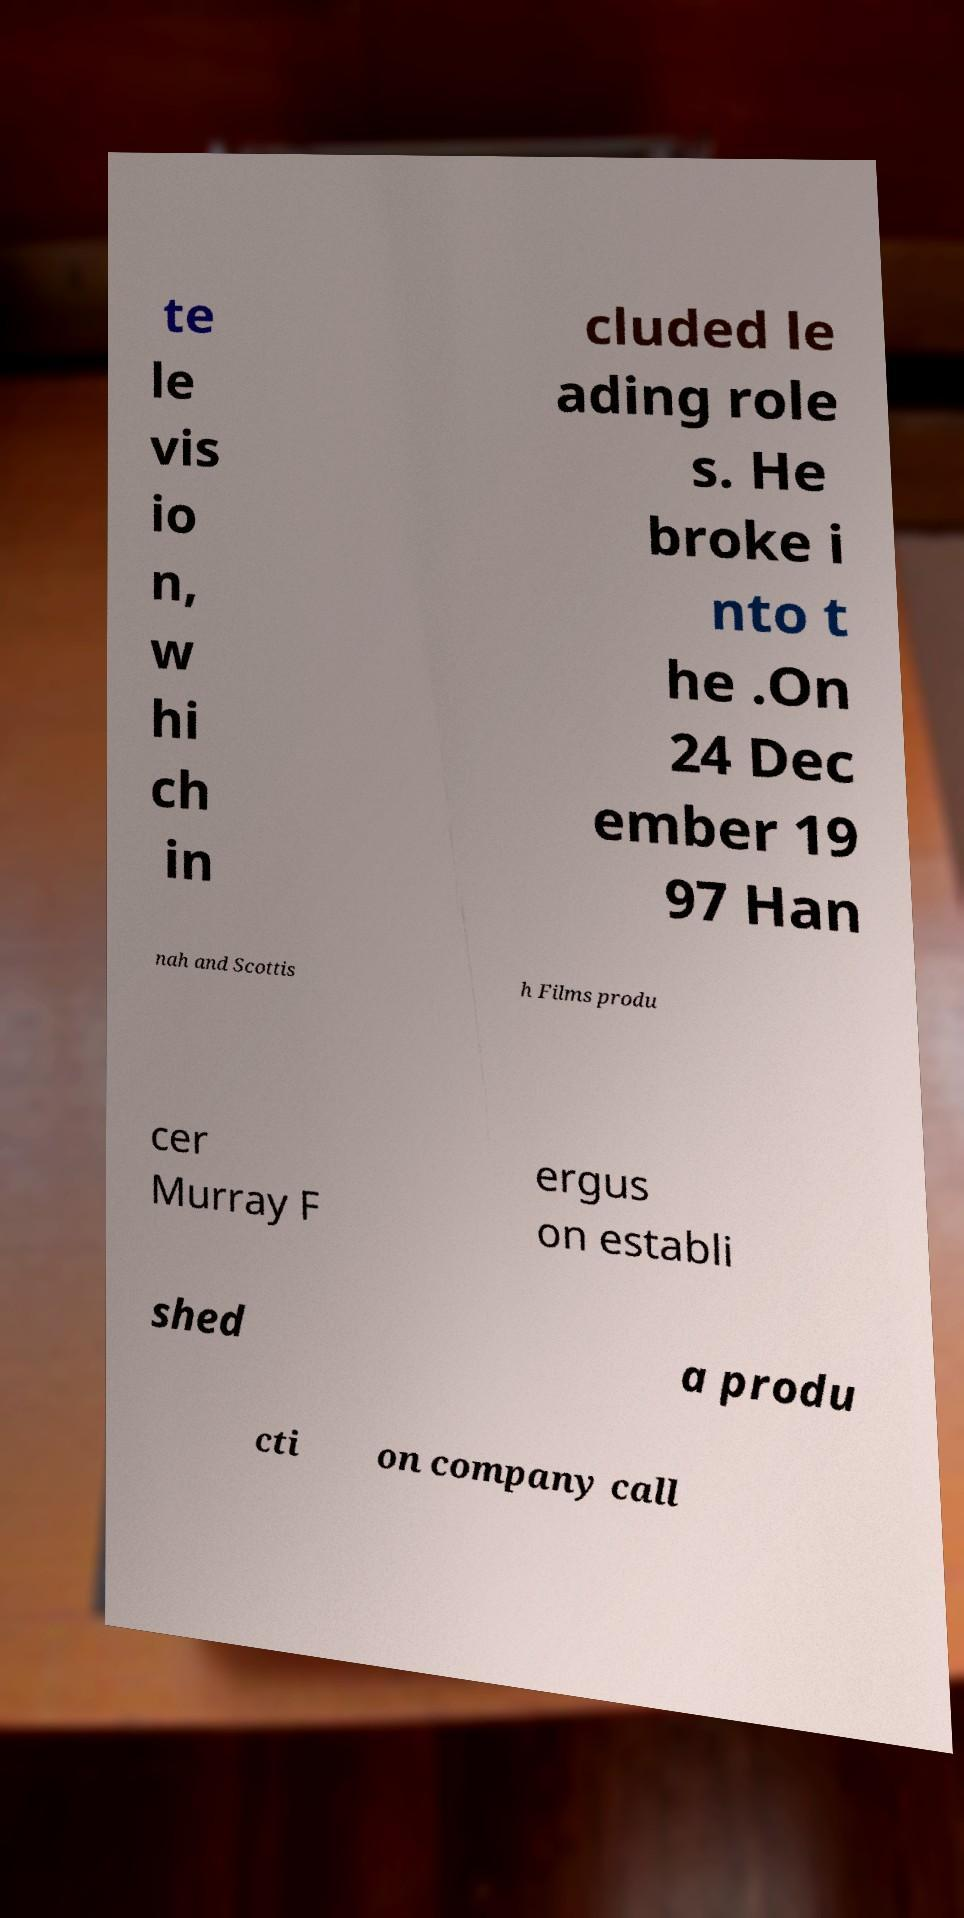Please read and relay the text visible in this image. What does it say? te le vis io n, w hi ch in cluded le ading role s. He broke i nto t he .On 24 Dec ember 19 97 Han nah and Scottis h Films produ cer Murray F ergus on establi shed a produ cti on company call 